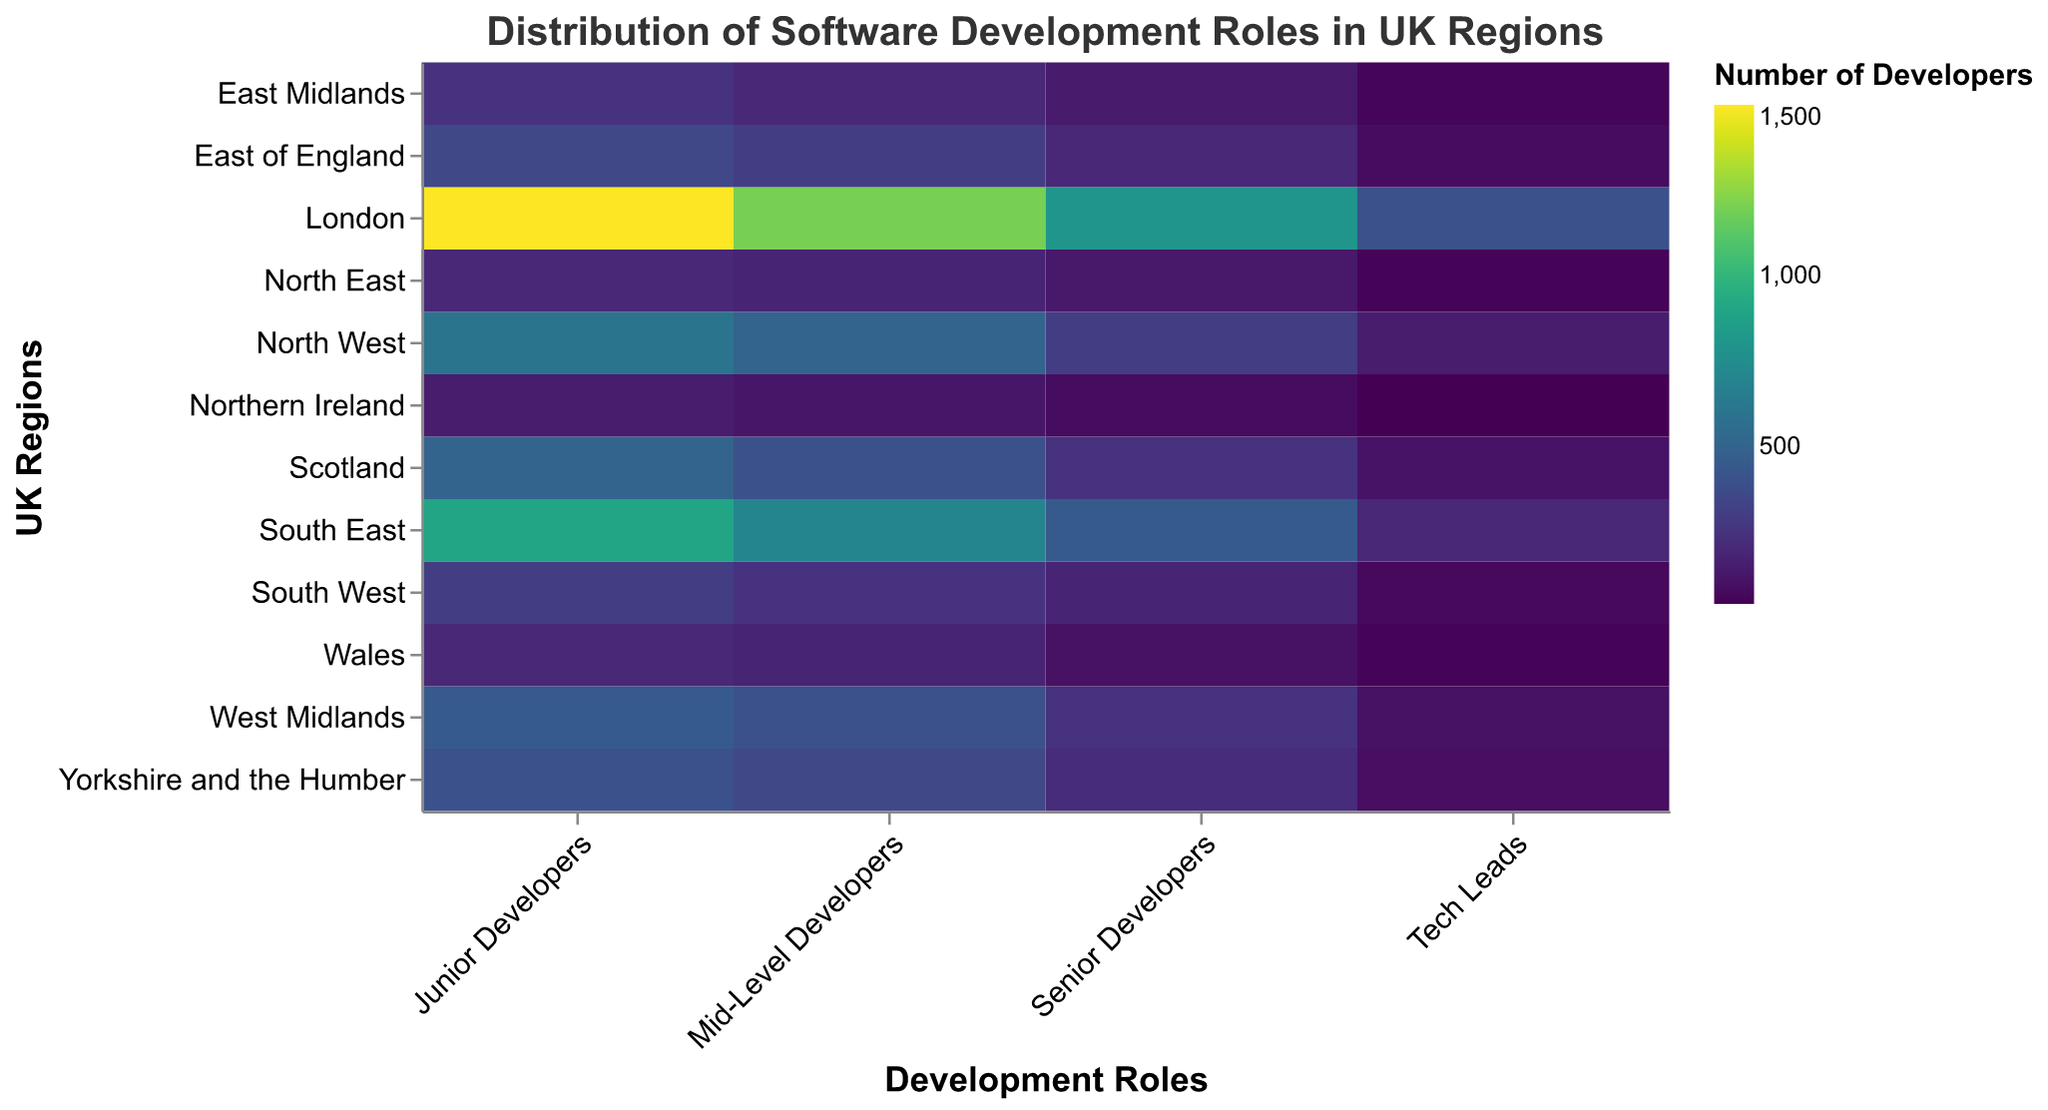What is the title of the heatmap? Look at the top of the figure where the title is displayed in a larger font size. The title should give a concise description of what the figure represents.
Answer: Distribution of Software Development Roles in UK Regions Which region has the highest number of Junior Developers? Look for the highest value in the 'Junior Developers' column and correlate it with the 'Region' row.
Answer: London How many Tech Leads are there in Scotland? Find the row labeled 'Scotland' and follow it to the 'Tech Leads' column to identify the count.
Answer: 110 What role has the lowest count in Northern Ireland? Examine the row labeled 'Northern Ireland' and compare the counts for each role.
Answer: Tech Leads Which role is most prevalent across all regions according to the heatmap colors? Refer to the color intensity of each role across all regions; the role with the most frequent and brightest color represents the highest counts overall.
Answer: Junior Developers Compare the number of Mid-Level Developers in the South East and North West. Locate the counts for 'Mid-Level Developers' in both 'South East' and 'North West' and compare them.
Answer: South East (700) has more than North West (500) What's the sum of Senior Developers in Wales and the North East? Find the counts for 'Senior Developers' in both 'Wales' and 'North East' and add them together (100 + 130).
Answer: 230 Which region has the closest number of Mid-Level Developers to the number of Junior Developers in the East Midlands? Check the 'Mid-Level Developers' column for counts that are close to 250 (the count of Junior Developers in the East Midlands) and verify the region.
Answer: Scotland Identify the region with the lowest number of Mid-Level Developers. Search for the lowest value in the 'Mid-Level Developers' column and check the corresponding region.
Answer: Northern Ireland How many more Senior Developers are there in London compared to the South West? Subtract the count of 'Senior Developers' in 'South West' from 'Senior Developers' in 'London' (800 - 180).
Answer: 620 